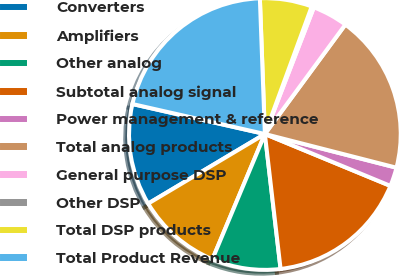Convert chart to OTSL. <chart><loc_0><loc_0><loc_500><loc_500><pie_chart><fcel>Converters<fcel>Amplifiers<fcel>Other analog<fcel>Subtotal analog signal<fcel>Power management & reference<fcel>Total analog products<fcel>General purpose DSP<fcel>Other DSP<fcel>Total DSP products<fcel>Total Product Revenue<nl><fcel>12.1%<fcel>10.13%<fcel>8.16%<fcel>16.92%<fcel>2.25%<fcel>18.9%<fcel>4.22%<fcel>0.27%<fcel>6.19%<fcel>20.87%<nl></chart> 